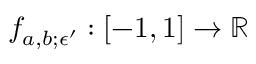Convert formula to latex. <formula><loc_0><loc_0><loc_500><loc_500>f _ { a , b ; \epsilon ^ { \prime } } \colon [ - 1 , 1 ] \to \mathbb { R }</formula> 